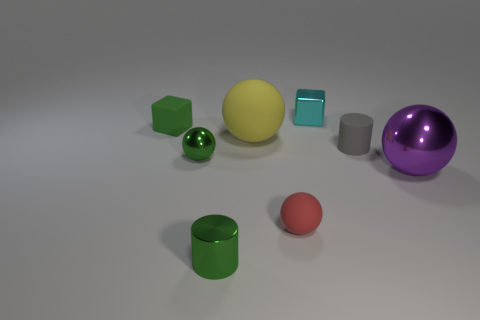Subtract 1 spheres. How many spheres are left? 3 Add 2 red objects. How many objects exist? 10 Subtract all cylinders. How many objects are left? 6 Add 4 large purple objects. How many large purple objects are left? 5 Add 4 large red cylinders. How many large red cylinders exist? 4 Subtract 0 yellow cubes. How many objects are left? 8 Subtract all green matte cubes. Subtract all red rubber spheres. How many objects are left? 6 